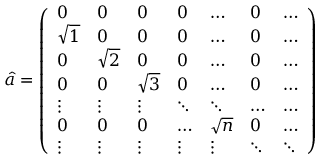<formula> <loc_0><loc_0><loc_500><loc_500>\hat { a } = \left ( \begin{array} { l l l l l l l } { 0 } & { 0 } & { 0 } & { 0 } & { \dots } & { 0 } & { \dots } \\ { \sqrt { 1 } } & { 0 } & { 0 } & { 0 } & { \dots } & { 0 } & { \dots } \\ { 0 } & { \sqrt { 2 } } & { 0 } & { 0 } & { \dots } & { 0 } & { \dots } \\ { 0 } & { 0 } & { \sqrt { 3 } } & { 0 } & { \dots } & { 0 } & { \dots } \\ { \vdots } & { \vdots } & { \vdots } & { \ddots } & { \ddots } & { \dots } & { \dots } \\ { 0 } & { 0 } & { 0 } & { \dots } & { \sqrt { n } } & { 0 } & { \dots } \\ { \vdots } & { \vdots } & { \vdots } & { \vdots } & { \vdots } & { \ddots } & { \ddots } \end{array} \right )</formula> 